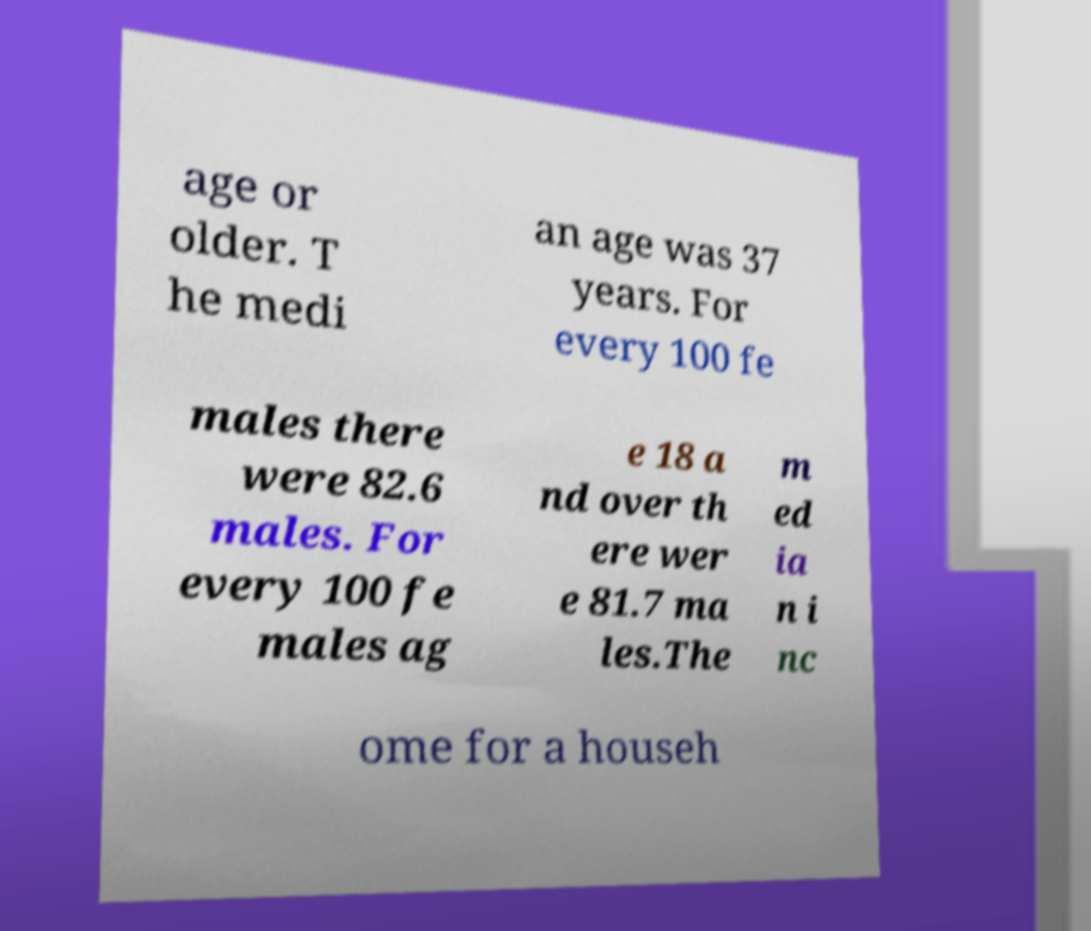What messages or text are displayed in this image? I need them in a readable, typed format. age or older. T he medi an age was 37 years. For every 100 fe males there were 82.6 males. For every 100 fe males ag e 18 a nd over th ere wer e 81.7 ma les.The m ed ia n i nc ome for a househ 